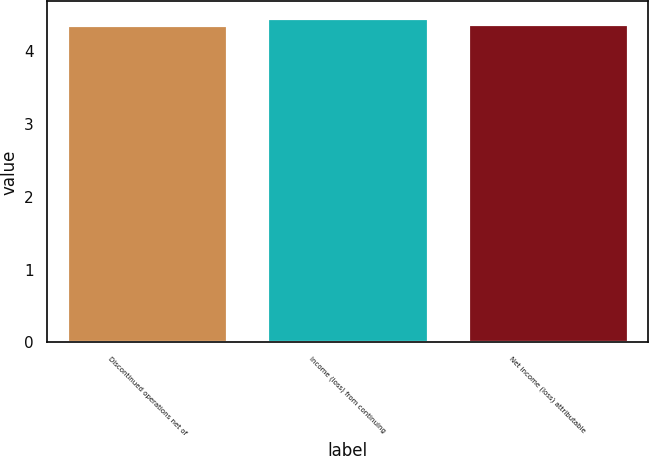Convert chart to OTSL. <chart><loc_0><loc_0><loc_500><loc_500><bar_chart><fcel>Discontinued operations net of<fcel>Income (loss) from continuing<fcel>Net income (loss) attributable<nl><fcel>4.36<fcel>4.46<fcel>4.37<nl></chart> 